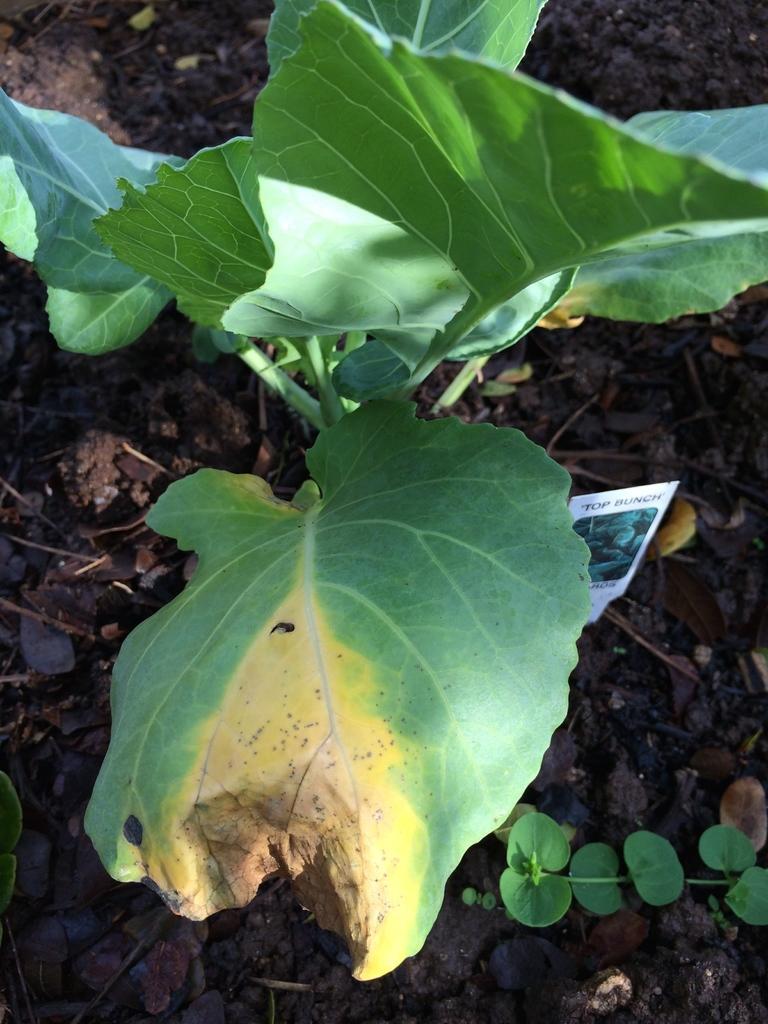How would you summarize this image in a sentence or two? In this image I can see few green color leaves,few stones and mud. I can see a white color object and something is written on it. 